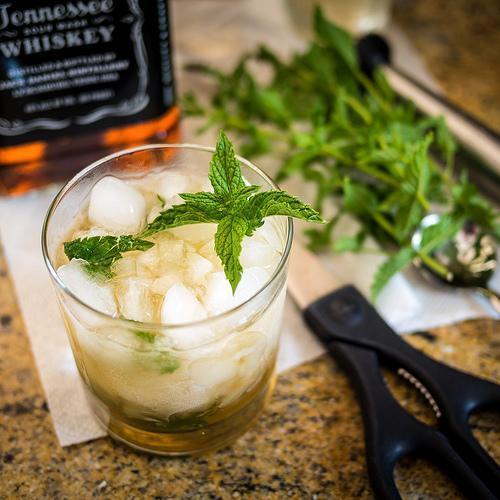How many drinks are on the table?
Give a very brief answer. 1. 